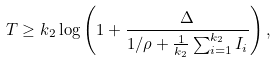Convert formula to latex. <formula><loc_0><loc_0><loc_500><loc_500>T \geq k _ { 2 } \log \left ( 1 + \frac { \Delta } { 1 / \rho + \frac { 1 } { k _ { 2 } } \sum _ { i = 1 } ^ { k _ { 2 } } I _ { i } } \right ) ,</formula> 